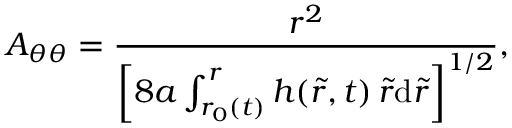Convert formula to latex. <formula><loc_0><loc_0><loc_500><loc_500>A _ { \theta \theta } = \frac { r ^ { 2 } } { \left [ 8 a \int _ { r _ { 0 } ( t ) } ^ { r } h ( \tilde { r } , t ) \, \tilde { r } d \tilde { r } \right ] ^ { 1 / 2 } } ,</formula> 